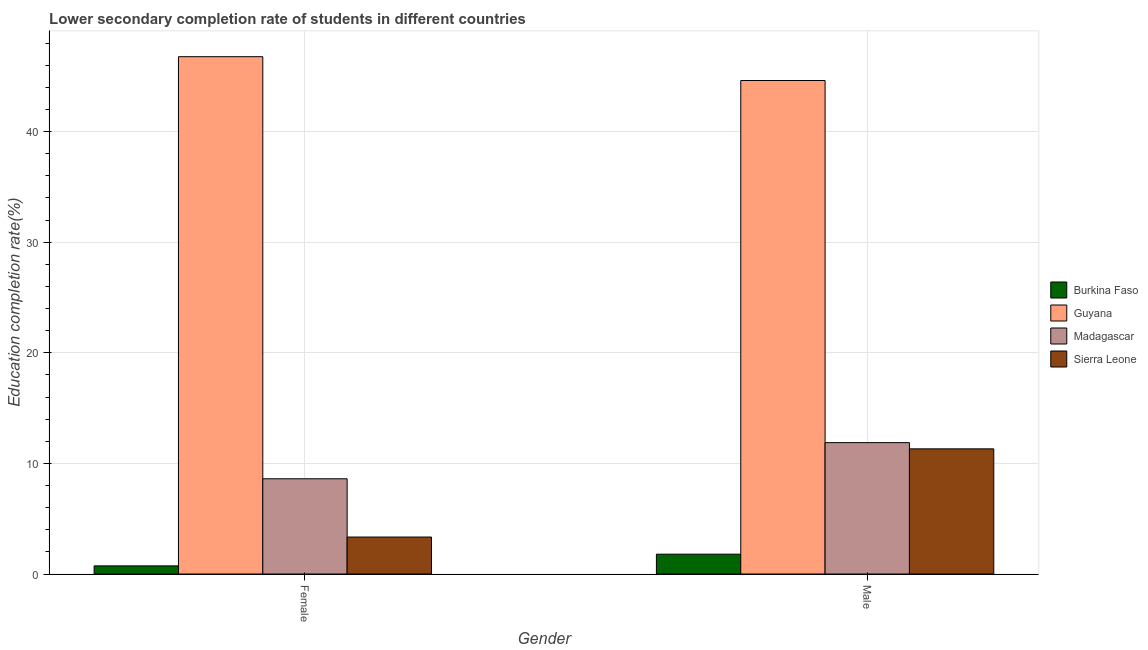How many groups of bars are there?
Offer a very short reply. 2. Are the number of bars on each tick of the X-axis equal?
Ensure brevity in your answer.  Yes. How many bars are there on the 2nd tick from the left?
Provide a short and direct response. 4. What is the label of the 2nd group of bars from the left?
Provide a succinct answer. Male. What is the education completion rate of female students in Guyana?
Make the answer very short. 46.76. Across all countries, what is the maximum education completion rate of male students?
Offer a terse response. 44.61. Across all countries, what is the minimum education completion rate of female students?
Give a very brief answer. 0.73. In which country was the education completion rate of female students maximum?
Keep it short and to the point. Guyana. In which country was the education completion rate of female students minimum?
Offer a very short reply. Burkina Faso. What is the total education completion rate of male students in the graph?
Ensure brevity in your answer.  69.59. What is the difference between the education completion rate of female students in Sierra Leone and that in Madagascar?
Keep it short and to the point. -5.27. What is the difference between the education completion rate of female students in Burkina Faso and the education completion rate of male students in Guyana?
Your answer should be compact. -43.88. What is the average education completion rate of female students per country?
Provide a short and direct response. 14.86. What is the difference between the education completion rate of female students and education completion rate of male students in Burkina Faso?
Offer a very short reply. -1.06. In how many countries, is the education completion rate of female students greater than 42 %?
Ensure brevity in your answer.  1. What is the ratio of the education completion rate of female students in Sierra Leone to that in Guyana?
Keep it short and to the point. 0.07. In how many countries, is the education completion rate of female students greater than the average education completion rate of female students taken over all countries?
Offer a very short reply. 1. What does the 2nd bar from the left in Female represents?
Ensure brevity in your answer.  Guyana. What does the 1st bar from the right in Male represents?
Make the answer very short. Sierra Leone. How many bars are there?
Your answer should be compact. 8. Are all the bars in the graph horizontal?
Offer a terse response. No. How many countries are there in the graph?
Your response must be concise. 4. Does the graph contain grids?
Provide a succinct answer. Yes. Where does the legend appear in the graph?
Ensure brevity in your answer.  Center right. How are the legend labels stacked?
Keep it short and to the point. Vertical. What is the title of the graph?
Provide a succinct answer. Lower secondary completion rate of students in different countries. What is the label or title of the Y-axis?
Offer a very short reply. Education completion rate(%). What is the Education completion rate(%) of Burkina Faso in Female?
Give a very brief answer. 0.73. What is the Education completion rate(%) in Guyana in Female?
Give a very brief answer. 46.76. What is the Education completion rate(%) of Madagascar in Female?
Provide a short and direct response. 8.61. What is the Education completion rate(%) of Sierra Leone in Female?
Keep it short and to the point. 3.34. What is the Education completion rate(%) of Burkina Faso in Male?
Provide a succinct answer. 1.79. What is the Education completion rate(%) in Guyana in Male?
Offer a very short reply. 44.61. What is the Education completion rate(%) of Madagascar in Male?
Offer a terse response. 11.88. What is the Education completion rate(%) in Sierra Leone in Male?
Offer a terse response. 11.31. Across all Gender, what is the maximum Education completion rate(%) in Burkina Faso?
Provide a short and direct response. 1.79. Across all Gender, what is the maximum Education completion rate(%) in Guyana?
Provide a succinct answer. 46.76. Across all Gender, what is the maximum Education completion rate(%) in Madagascar?
Ensure brevity in your answer.  11.88. Across all Gender, what is the maximum Education completion rate(%) of Sierra Leone?
Provide a short and direct response. 11.31. Across all Gender, what is the minimum Education completion rate(%) in Burkina Faso?
Your answer should be very brief. 0.73. Across all Gender, what is the minimum Education completion rate(%) of Guyana?
Give a very brief answer. 44.61. Across all Gender, what is the minimum Education completion rate(%) of Madagascar?
Offer a terse response. 8.61. Across all Gender, what is the minimum Education completion rate(%) of Sierra Leone?
Offer a terse response. 3.34. What is the total Education completion rate(%) of Burkina Faso in the graph?
Your response must be concise. 2.53. What is the total Education completion rate(%) in Guyana in the graph?
Your answer should be very brief. 91.37. What is the total Education completion rate(%) of Madagascar in the graph?
Ensure brevity in your answer.  20.48. What is the total Education completion rate(%) in Sierra Leone in the graph?
Your response must be concise. 14.65. What is the difference between the Education completion rate(%) in Burkina Faso in Female and that in Male?
Your answer should be very brief. -1.06. What is the difference between the Education completion rate(%) in Guyana in Female and that in Male?
Provide a short and direct response. 2.15. What is the difference between the Education completion rate(%) in Madagascar in Female and that in Male?
Make the answer very short. -3.27. What is the difference between the Education completion rate(%) in Sierra Leone in Female and that in Male?
Offer a very short reply. -7.97. What is the difference between the Education completion rate(%) in Burkina Faso in Female and the Education completion rate(%) in Guyana in Male?
Give a very brief answer. -43.88. What is the difference between the Education completion rate(%) in Burkina Faso in Female and the Education completion rate(%) in Madagascar in Male?
Your answer should be very brief. -11.14. What is the difference between the Education completion rate(%) in Burkina Faso in Female and the Education completion rate(%) in Sierra Leone in Male?
Offer a terse response. -10.58. What is the difference between the Education completion rate(%) in Guyana in Female and the Education completion rate(%) in Madagascar in Male?
Give a very brief answer. 34.89. What is the difference between the Education completion rate(%) of Guyana in Female and the Education completion rate(%) of Sierra Leone in Male?
Your answer should be very brief. 35.45. What is the difference between the Education completion rate(%) in Madagascar in Female and the Education completion rate(%) in Sierra Leone in Male?
Make the answer very short. -2.7. What is the average Education completion rate(%) in Burkina Faso per Gender?
Offer a very short reply. 1.26. What is the average Education completion rate(%) in Guyana per Gender?
Make the answer very short. 45.69. What is the average Education completion rate(%) in Madagascar per Gender?
Your answer should be compact. 10.24. What is the average Education completion rate(%) in Sierra Leone per Gender?
Make the answer very short. 7.33. What is the difference between the Education completion rate(%) of Burkina Faso and Education completion rate(%) of Guyana in Female?
Provide a short and direct response. -46.03. What is the difference between the Education completion rate(%) in Burkina Faso and Education completion rate(%) in Madagascar in Female?
Your answer should be compact. -7.87. What is the difference between the Education completion rate(%) in Burkina Faso and Education completion rate(%) in Sierra Leone in Female?
Give a very brief answer. -2.61. What is the difference between the Education completion rate(%) in Guyana and Education completion rate(%) in Madagascar in Female?
Your answer should be very brief. 38.15. What is the difference between the Education completion rate(%) of Guyana and Education completion rate(%) of Sierra Leone in Female?
Give a very brief answer. 43.42. What is the difference between the Education completion rate(%) in Madagascar and Education completion rate(%) in Sierra Leone in Female?
Offer a terse response. 5.27. What is the difference between the Education completion rate(%) in Burkina Faso and Education completion rate(%) in Guyana in Male?
Give a very brief answer. -42.82. What is the difference between the Education completion rate(%) in Burkina Faso and Education completion rate(%) in Madagascar in Male?
Give a very brief answer. -10.08. What is the difference between the Education completion rate(%) in Burkina Faso and Education completion rate(%) in Sierra Leone in Male?
Make the answer very short. -9.52. What is the difference between the Education completion rate(%) in Guyana and Education completion rate(%) in Madagascar in Male?
Your response must be concise. 32.74. What is the difference between the Education completion rate(%) of Guyana and Education completion rate(%) of Sierra Leone in Male?
Ensure brevity in your answer.  33.3. What is the difference between the Education completion rate(%) in Madagascar and Education completion rate(%) in Sierra Leone in Male?
Provide a succinct answer. 0.56. What is the ratio of the Education completion rate(%) of Burkina Faso in Female to that in Male?
Make the answer very short. 0.41. What is the ratio of the Education completion rate(%) of Guyana in Female to that in Male?
Make the answer very short. 1.05. What is the ratio of the Education completion rate(%) in Madagascar in Female to that in Male?
Offer a terse response. 0.72. What is the ratio of the Education completion rate(%) in Sierra Leone in Female to that in Male?
Your answer should be very brief. 0.3. What is the difference between the highest and the second highest Education completion rate(%) in Burkina Faso?
Your answer should be very brief. 1.06. What is the difference between the highest and the second highest Education completion rate(%) in Guyana?
Ensure brevity in your answer.  2.15. What is the difference between the highest and the second highest Education completion rate(%) in Madagascar?
Provide a short and direct response. 3.27. What is the difference between the highest and the second highest Education completion rate(%) of Sierra Leone?
Keep it short and to the point. 7.97. What is the difference between the highest and the lowest Education completion rate(%) of Burkina Faso?
Offer a terse response. 1.06. What is the difference between the highest and the lowest Education completion rate(%) of Guyana?
Your answer should be very brief. 2.15. What is the difference between the highest and the lowest Education completion rate(%) in Madagascar?
Offer a very short reply. 3.27. What is the difference between the highest and the lowest Education completion rate(%) in Sierra Leone?
Your response must be concise. 7.97. 